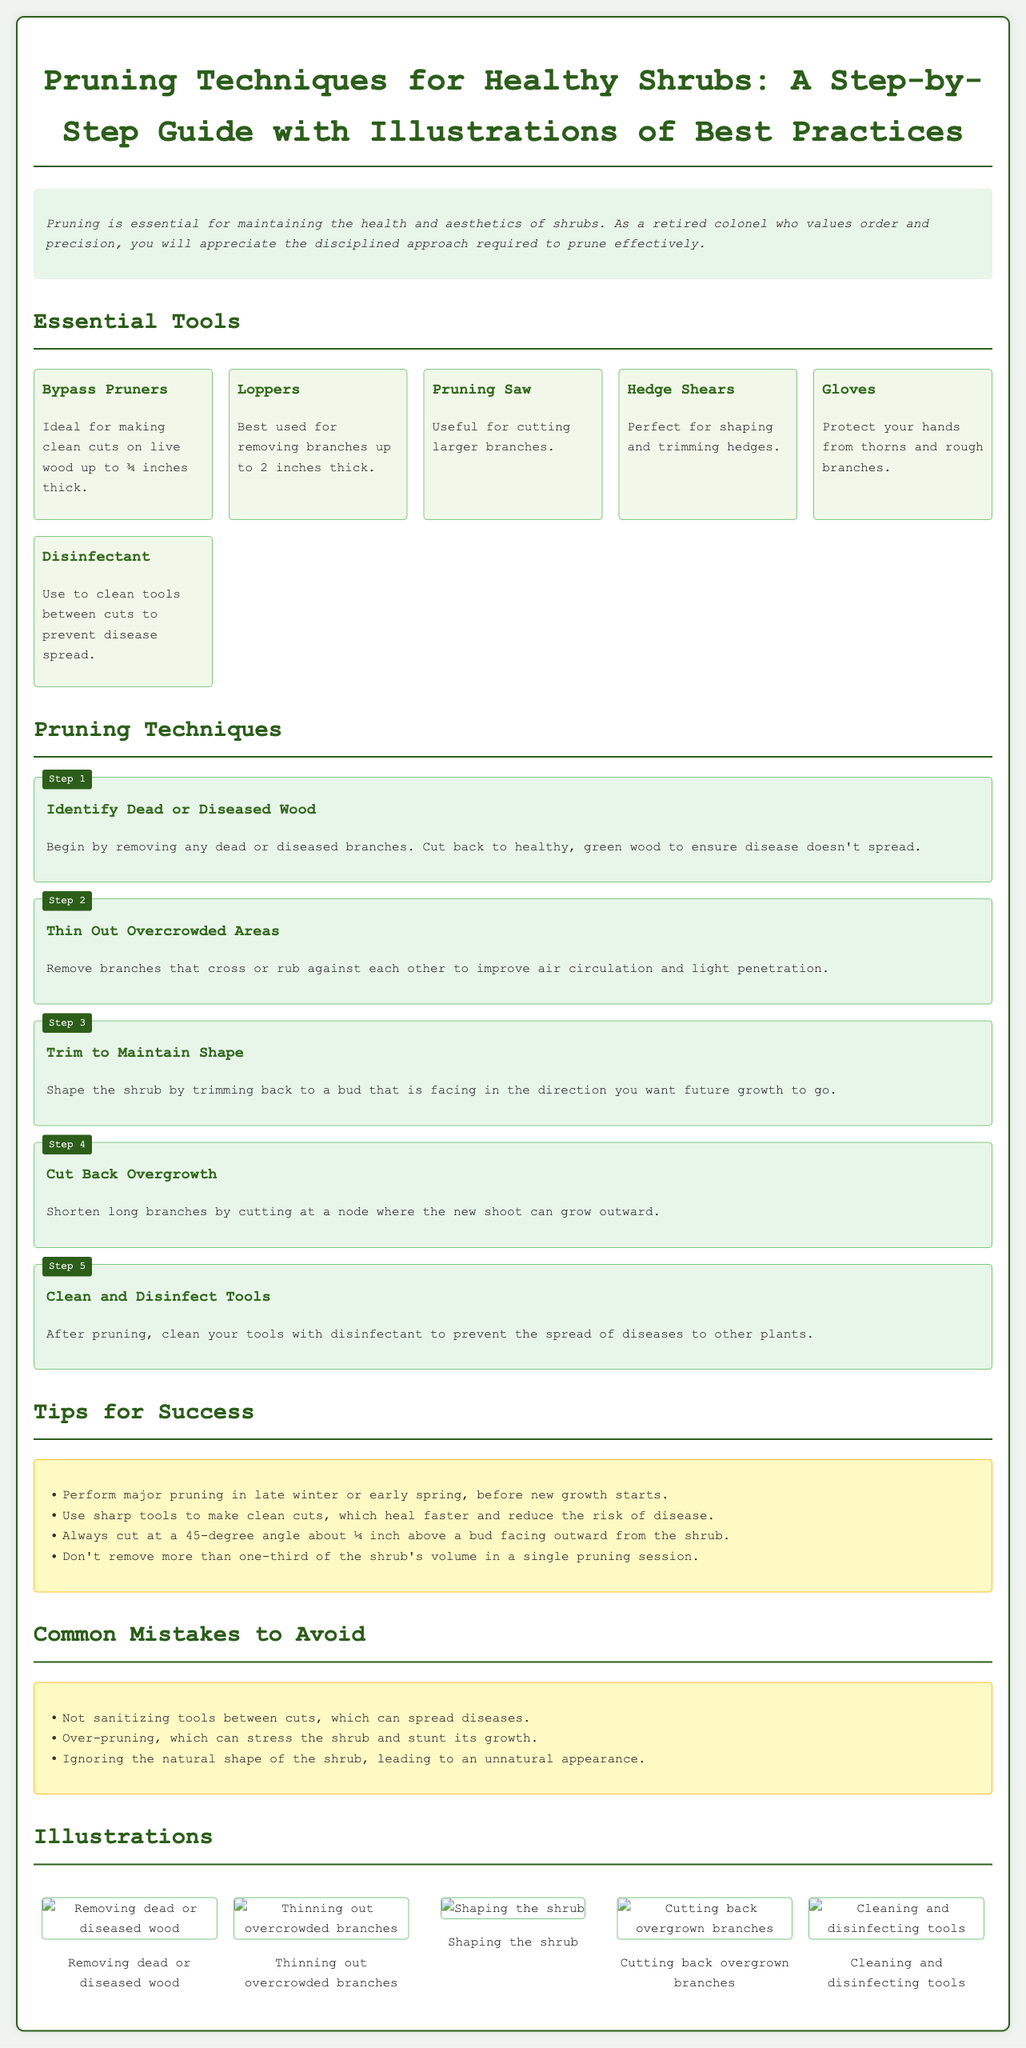What is the title of the document? The title is prominently displayed at the top of the document, encapsulating the main topic discussed.
Answer: Pruning Techniques for Healthy Shrubs: A Step-by-Step Guide with Illustrations of Best Practices How many essential tools are listed? The number of essential tools can be counted in the section that details the required tools for pruning.
Answer: Six What is the first step in the pruning process? The first step is outlined at the beginning of the list of steps for pruning techniques to follow.
Answer: Identify Dead or Diseased Wood What is a tip for successful pruning? Tips are provided in a separate section, detailing best practices that should be followed during the pruning process.
Answer: Perform major pruning in late winter or early spring, before new growth starts What is one common mistake to avoid when pruning? Common mistakes are listed in a section that highlights what should be avoided during the pruning process.
Answer: Not sanitizing tools between cuts What should you cut to maintain the shrub's shape? The specific action that should be taken to maintain shape is explained in the detailed steps for pruning.
Answer: Trim back to a bud facing outward What type of pruner is ideal for clean cuts on live wood? This information can be found in the tools section where each tool is described.
Answer: Bypass Pruners What is the suggested angle for cuts? The precise angle for cutting is mentioned within the tips for success, emphasizing the method for effective pruning.
Answer: 45-degree angle 